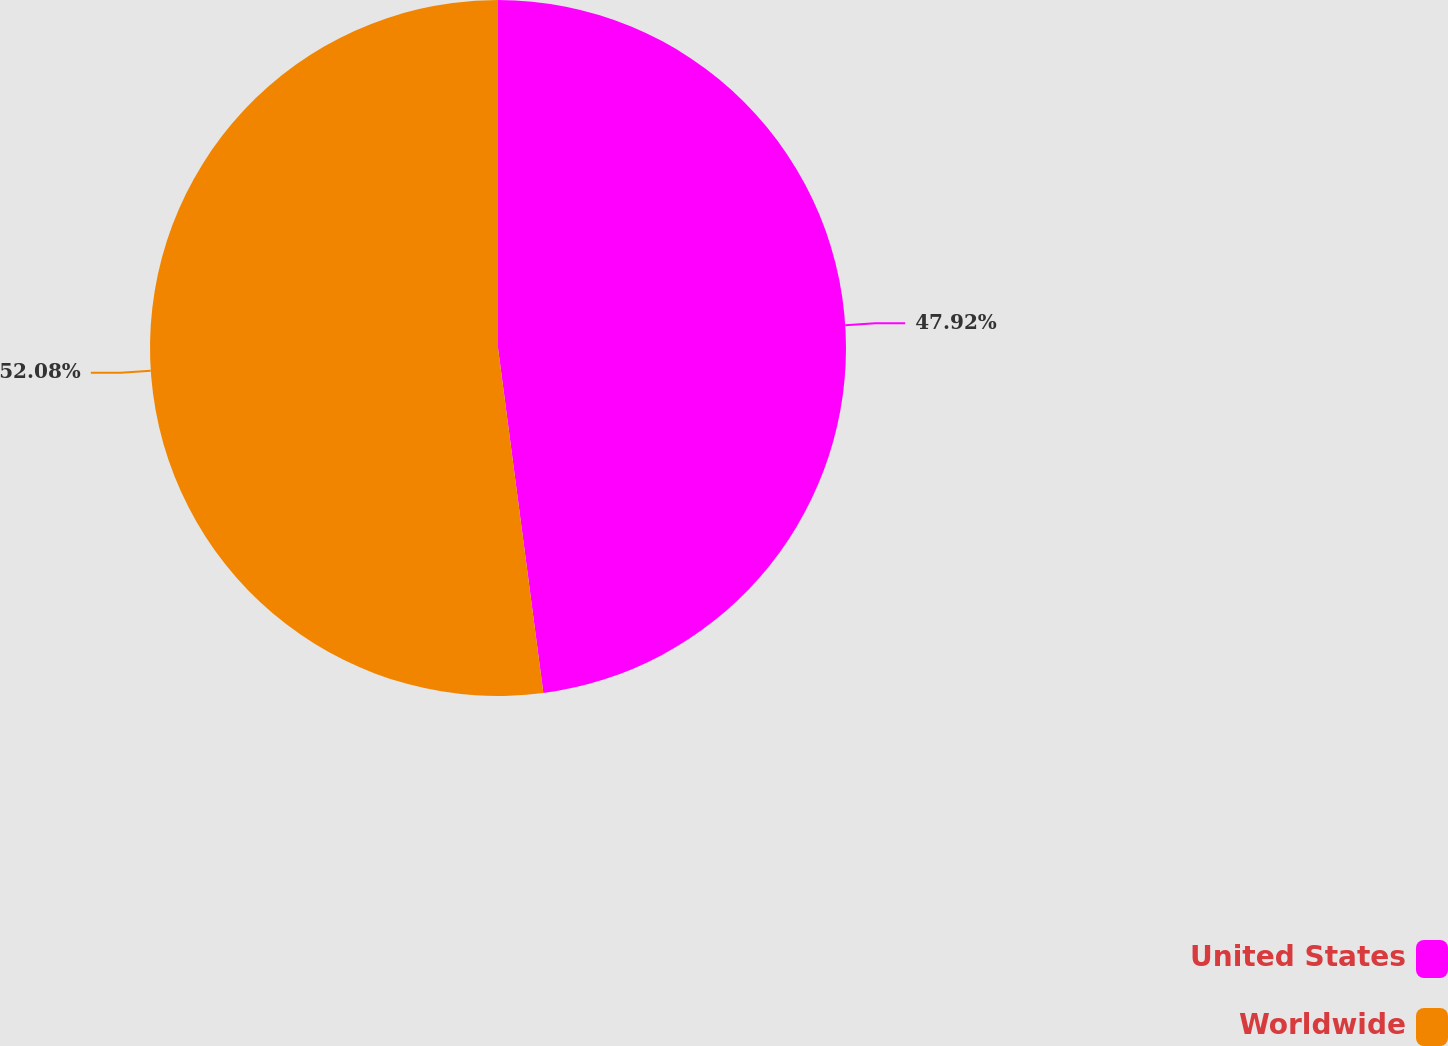<chart> <loc_0><loc_0><loc_500><loc_500><pie_chart><fcel>United States<fcel>Worldwide<nl><fcel>47.92%<fcel>52.08%<nl></chart> 